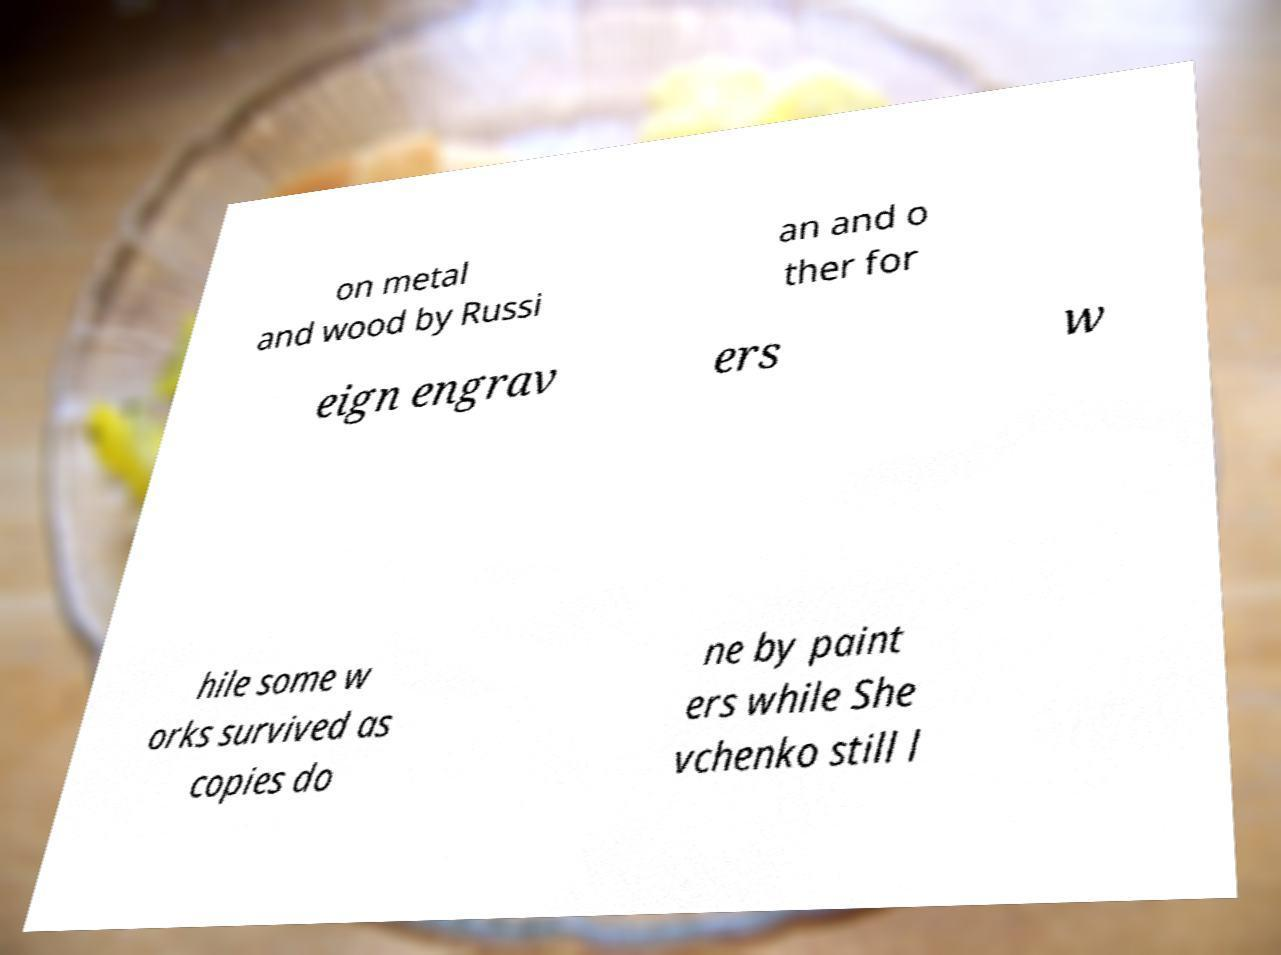Please identify and transcribe the text found in this image. on metal and wood by Russi an and o ther for eign engrav ers w hile some w orks survived as copies do ne by paint ers while She vchenko still l 